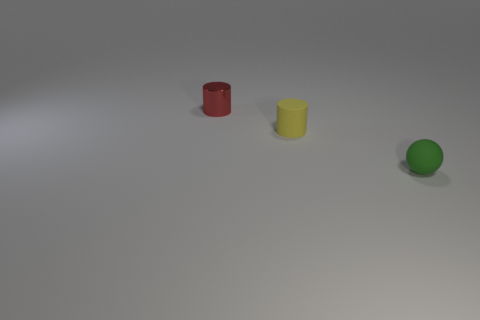Are there any tiny rubber spheres behind the cylinder that is to the right of the small red metallic object?
Give a very brief answer. No. Are there any green shiny cubes of the same size as the ball?
Your answer should be compact. No. Do the object in front of the rubber cylinder and the small matte cylinder have the same color?
Provide a succinct answer. No. The yellow matte object is what size?
Keep it short and to the point. Small. There is a matte ball to the right of the cylinder that is in front of the tiny red object; what is its size?
Your answer should be very brief. Small. How many things have the same color as the tiny shiny cylinder?
Keep it short and to the point. 0. How many green rubber balls are there?
Your answer should be compact. 1. How many tiny cylinders have the same material as the small green ball?
Keep it short and to the point. 1. What size is the other object that is the same shape as the tiny yellow thing?
Offer a very short reply. Small. What material is the small red object?
Provide a short and direct response. Metal. 